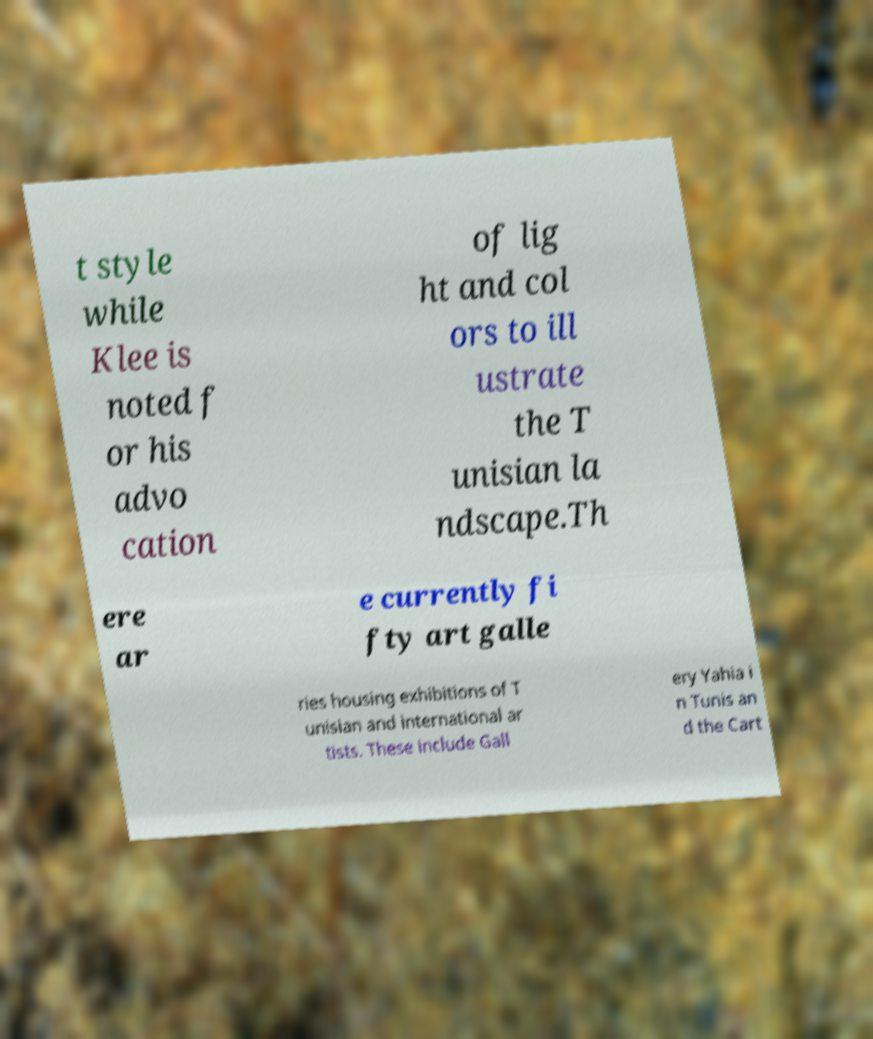Please read and relay the text visible in this image. What does it say? t style while Klee is noted f or his advo cation of lig ht and col ors to ill ustrate the T unisian la ndscape.Th ere ar e currently fi fty art galle ries housing exhibitions of T unisian and international ar tists. These include Gall ery Yahia i n Tunis an d the Cart 